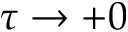Convert formula to latex. <formula><loc_0><loc_0><loc_500><loc_500>\tau \to + 0</formula> 